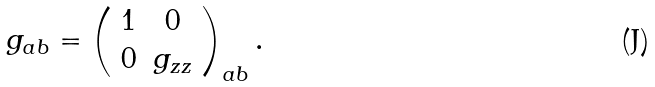<formula> <loc_0><loc_0><loc_500><loc_500>g _ { a b } = \left ( \begin{array} { c c } 1 & 0 \\ 0 & g _ { z z } \end{array} \right ) _ { a b } .</formula> 